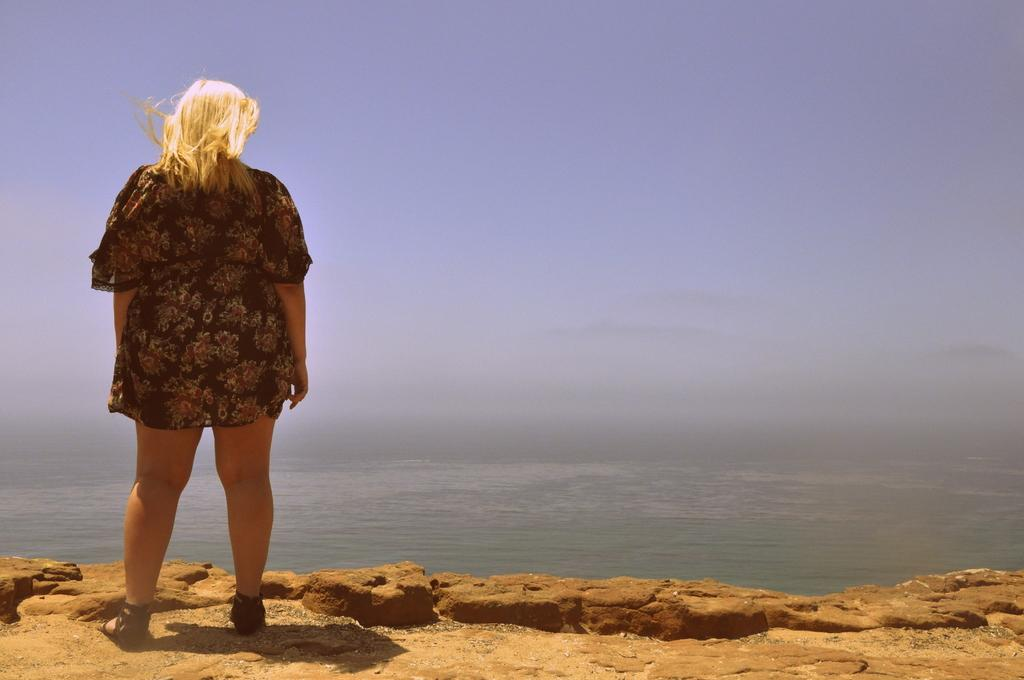What is the main subject on the left side of the image? There is a woman standing on a rock on the left side of the image. What can be seen in the center of the image? There is a water body in the center of the image. What is visible at the top of the image? The sky is visible at the top of the image. What type of cheese is being used to feed the cattle in the image? There is no cheese or cattle present in the image. Where is the kettle located in the image? There is no kettle present in the image. 